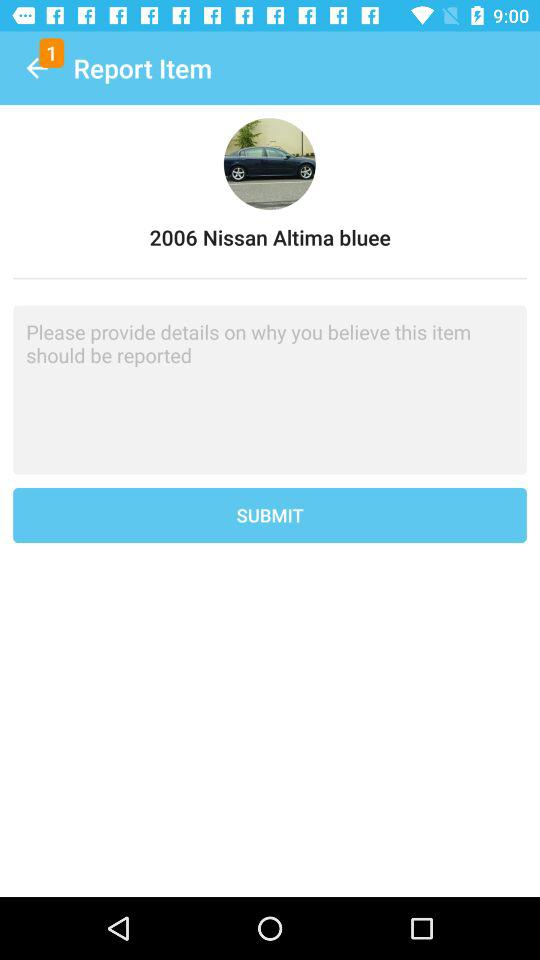What is the product name which is reported? The product name is "2006 Nissan Altima bluee". 